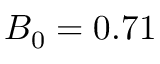<formula> <loc_0><loc_0><loc_500><loc_500>B _ { 0 } = 0 . 7 1</formula> 